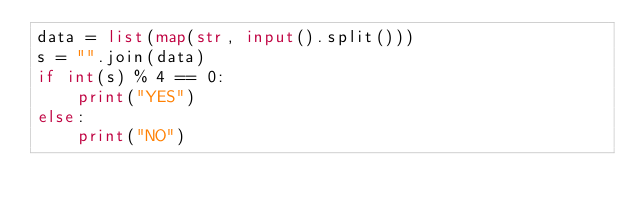Convert code to text. <code><loc_0><loc_0><loc_500><loc_500><_Python_>data = list(map(str, input().split()))
s = "".join(data)
if int(s) % 4 == 0:
    print("YES")
else:
    print("NO")
</code> 